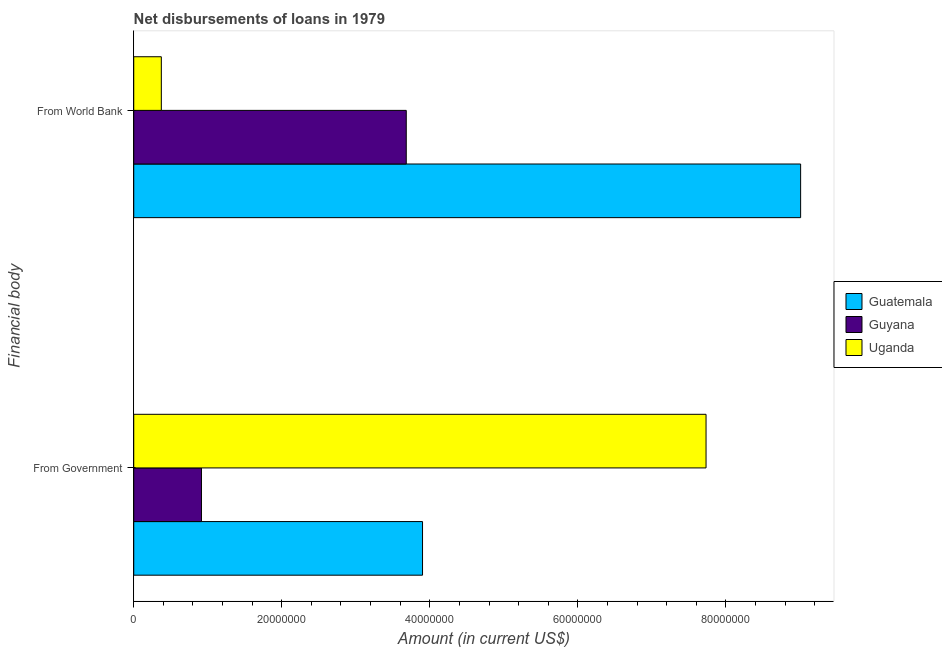How many bars are there on the 2nd tick from the top?
Your answer should be very brief. 3. How many bars are there on the 2nd tick from the bottom?
Ensure brevity in your answer.  3. What is the label of the 2nd group of bars from the top?
Your answer should be compact. From Government. What is the net disbursements of loan from world bank in Guatemala?
Ensure brevity in your answer.  9.01e+07. Across all countries, what is the maximum net disbursements of loan from government?
Provide a short and direct response. 7.73e+07. Across all countries, what is the minimum net disbursements of loan from world bank?
Ensure brevity in your answer.  3.73e+06. In which country was the net disbursements of loan from world bank maximum?
Your response must be concise. Guatemala. In which country was the net disbursements of loan from government minimum?
Make the answer very short. Guyana. What is the total net disbursements of loan from government in the graph?
Offer a very short reply. 1.25e+08. What is the difference between the net disbursements of loan from world bank in Guyana and that in Guatemala?
Keep it short and to the point. -5.33e+07. What is the difference between the net disbursements of loan from government in Guyana and the net disbursements of loan from world bank in Uganda?
Give a very brief answer. 5.42e+06. What is the average net disbursements of loan from government per country?
Keep it short and to the point. 4.18e+07. What is the difference between the net disbursements of loan from government and net disbursements of loan from world bank in Uganda?
Offer a very short reply. 7.36e+07. In how many countries, is the net disbursements of loan from world bank greater than 88000000 US$?
Ensure brevity in your answer.  1. What is the ratio of the net disbursements of loan from world bank in Guatemala to that in Guyana?
Your response must be concise. 2.45. Is the net disbursements of loan from government in Uganda less than that in Guyana?
Offer a very short reply. No. What does the 2nd bar from the top in From World Bank represents?
Offer a terse response. Guyana. What does the 2nd bar from the bottom in From World Bank represents?
Your answer should be compact. Guyana. How many bars are there?
Offer a terse response. 6. Are all the bars in the graph horizontal?
Ensure brevity in your answer.  Yes. How many countries are there in the graph?
Provide a succinct answer. 3. Are the values on the major ticks of X-axis written in scientific E-notation?
Give a very brief answer. No. Does the graph contain grids?
Your answer should be compact. No. What is the title of the graph?
Ensure brevity in your answer.  Net disbursements of loans in 1979. What is the label or title of the Y-axis?
Provide a succinct answer. Financial body. What is the Amount (in current US$) in Guatemala in From Government?
Offer a very short reply. 3.90e+07. What is the Amount (in current US$) in Guyana in From Government?
Offer a terse response. 9.15e+06. What is the Amount (in current US$) of Uganda in From Government?
Ensure brevity in your answer.  7.73e+07. What is the Amount (in current US$) of Guatemala in From World Bank?
Make the answer very short. 9.01e+07. What is the Amount (in current US$) in Guyana in From World Bank?
Provide a succinct answer. 3.68e+07. What is the Amount (in current US$) of Uganda in From World Bank?
Offer a very short reply. 3.73e+06. Across all Financial body, what is the maximum Amount (in current US$) of Guatemala?
Your answer should be compact. 9.01e+07. Across all Financial body, what is the maximum Amount (in current US$) of Guyana?
Offer a very short reply. 3.68e+07. Across all Financial body, what is the maximum Amount (in current US$) in Uganda?
Your response must be concise. 7.73e+07. Across all Financial body, what is the minimum Amount (in current US$) in Guatemala?
Offer a very short reply. 3.90e+07. Across all Financial body, what is the minimum Amount (in current US$) of Guyana?
Offer a terse response. 9.15e+06. Across all Financial body, what is the minimum Amount (in current US$) in Uganda?
Your answer should be compact. 3.73e+06. What is the total Amount (in current US$) in Guatemala in the graph?
Give a very brief answer. 1.29e+08. What is the total Amount (in current US$) of Guyana in the graph?
Your answer should be very brief. 4.60e+07. What is the total Amount (in current US$) in Uganda in the graph?
Keep it short and to the point. 8.11e+07. What is the difference between the Amount (in current US$) of Guatemala in From Government and that in From World Bank?
Your answer should be compact. -5.11e+07. What is the difference between the Amount (in current US$) in Guyana in From Government and that in From World Bank?
Offer a terse response. -2.77e+07. What is the difference between the Amount (in current US$) in Uganda in From Government and that in From World Bank?
Keep it short and to the point. 7.36e+07. What is the difference between the Amount (in current US$) of Guatemala in From Government and the Amount (in current US$) of Guyana in From World Bank?
Provide a short and direct response. 2.20e+06. What is the difference between the Amount (in current US$) of Guatemala in From Government and the Amount (in current US$) of Uganda in From World Bank?
Give a very brief answer. 3.53e+07. What is the difference between the Amount (in current US$) in Guyana in From Government and the Amount (in current US$) in Uganda in From World Bank?
Your response must be concise. 5.42e+06. What is the average Amount (in current US$) in Guatemala per Financial body?
Keep it short and to the point. 6.46e+07. What is the average Amount (in current US$) of Guyana per Financial body?
Your response must be concise. 2.30e+07. What is the average Amount (in current US$) in Uganda per Financial body?
Your answer should be very brief. 4.05e+07. What is the difference between the Amount (in current US$) of Guatemala and Amount (in current US$) of Guyana in From Government?
Provide a succinct answer. 2.99e+07. What is the difference between the Amount (in current US$) in Guatemala and Amount (in current US$) in Uganda in From Government?
Offer a terse response. -3.83e+07. What is the difference between the Amount (in current US$) of Guyana and Amount (in current US$) of Uganda in From Government?
Offer a terse response. -6.82e+07. What is the difference between the Amount (in current US$) in Guatemala and Amount (in current US$) in Guyana in From World Bank?
Your answer should be compact. 5.33e+07. What is the difference between the Amount (in current US$) in Guatemala and Amount (in current US$) in Uganda in From World Bank?
Provide a short and direct response. 8.64e+07. What is the difference between the Amount (in current US$) in Guyana and Amount (in current US$) in Uganda in From World Bank?
Provide a succinct answer. 3.31e+07. What is the ratio of the Amount (in current US$) in Guatemala in From Government to that in From World Bank?
Give a very brief answer. 0.43. What is the ratio of the Amount (in current US$) of Guyana in From Government to that in From World Bank?
Your answer should be compact. 0.25. What is the ratio of the Amount (in current US$) of Uganda in From Government to that in From World Bank?
Ensure brevity in your answer.  20.74. What is the difference between the highest and the second highest Amount (in current US$) of Guatemala?
Ensure brevity in your answer.  5.11e+07. What is the difference between the highest and the second highest Amount (in current US$) in Guyana?
Ensure brevity in your answer.  2.77e+07. What is the difference between the highest and the second highest Amount (in current US$) of Uganda?
Your answer should be compact. 7.36e+07. What is the difference between the highest and the lowest Amount (in current US$) of Guatemala?
Give a very brief answer. 5.11e+07. What is the difference between the highest and the lowest Amount (in current US$) in Guyana?
Give a very brief answer. 2.77e+07. What is the difference between the highest and the lowest Amount (in current US$) in Uganda?
Give a very brief answer. 7.36e+07. 